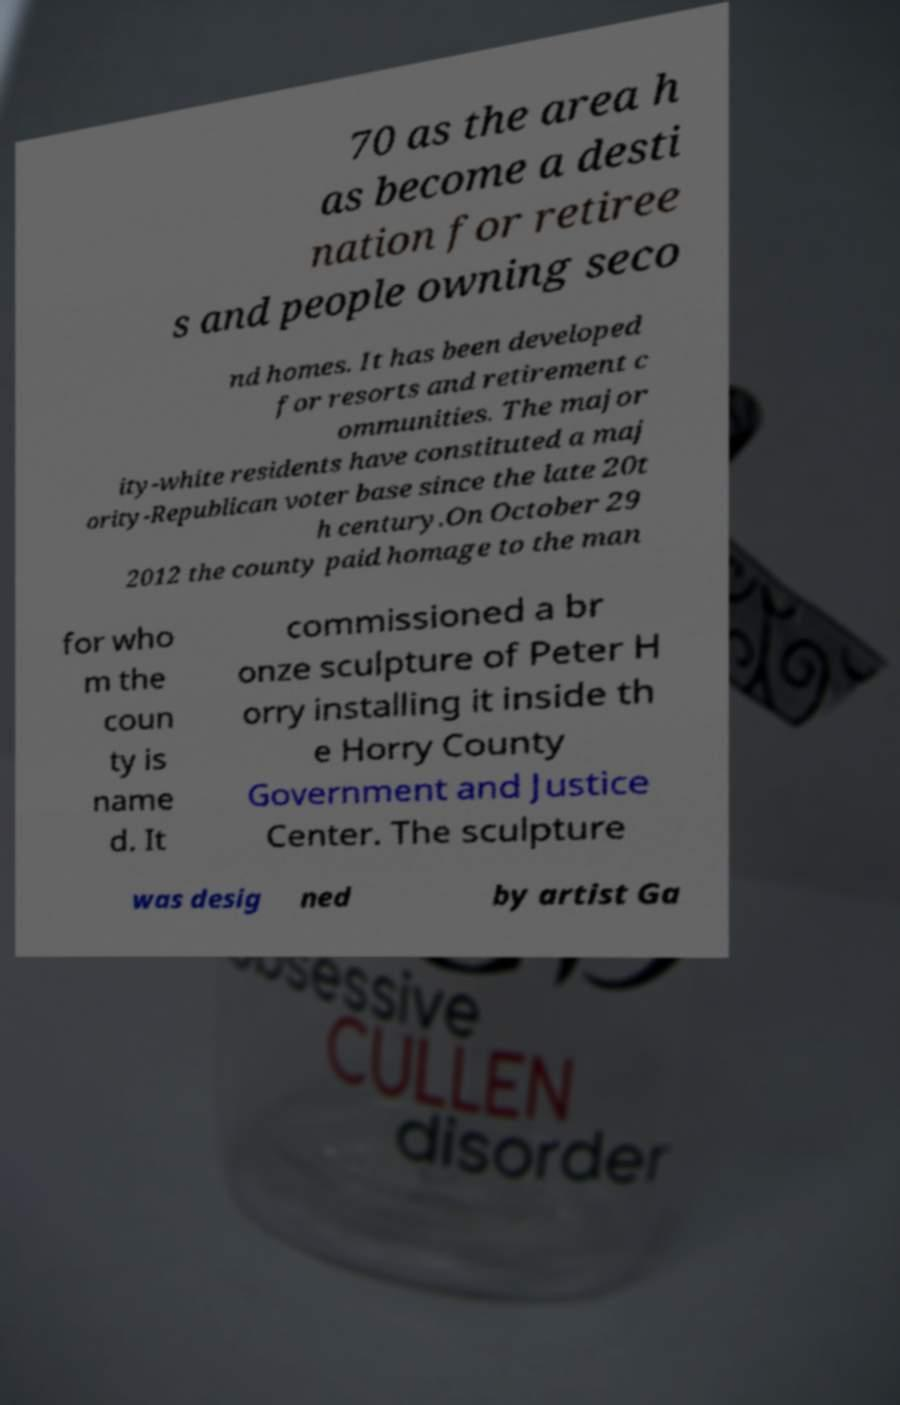Could you extract and type out the text from this image? 70 as the area h as become a desti nation for retiree s and people owning seco nd homes. It has been developed for resorts and retirement c ommunities. The major ity-white residents have constituted a maj ority-Republican voter base since the late 20t h century.On October 29 2012 the county paid homage to the man for who m the coun ty is name d. It commissioned a br onze sculpture of Peter H orry installing it inside th e Horry County Government and Justice Center. The sculpture was desig ned by artist Ga 